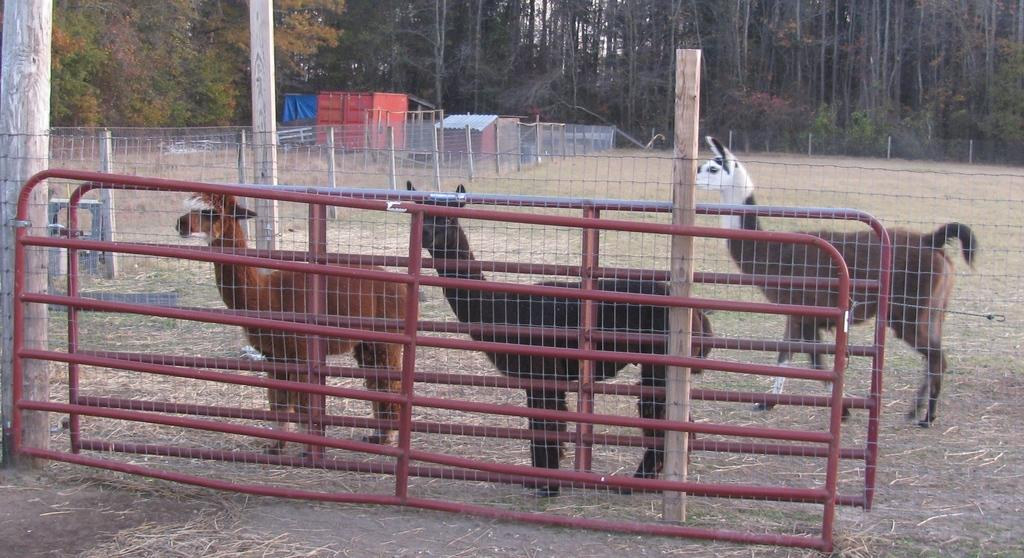What type of structure can be seen in the image? There is a fence in the image. What other living beings are present in the image? There are animals in the image. What object is used for storage or transportation in the image? There is a container in the image. What type of building is visible in the image? There is a house in the image. What type of vegetation is present in the image? There are trees in the image. What type of pan is being used to cook the animals in the image? There is no pan or cooking activity present in the image. What type of pain is the house experiencing in the image? There is no indication of pain or any emotional state for the house in the image. 